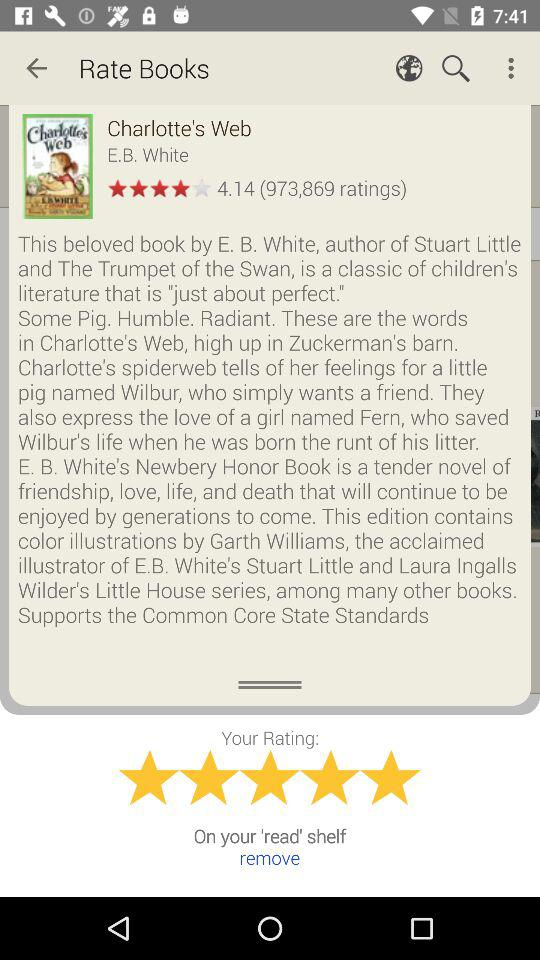What is the rating of the book "Charlotte's Web"? The rating is 4.14. 